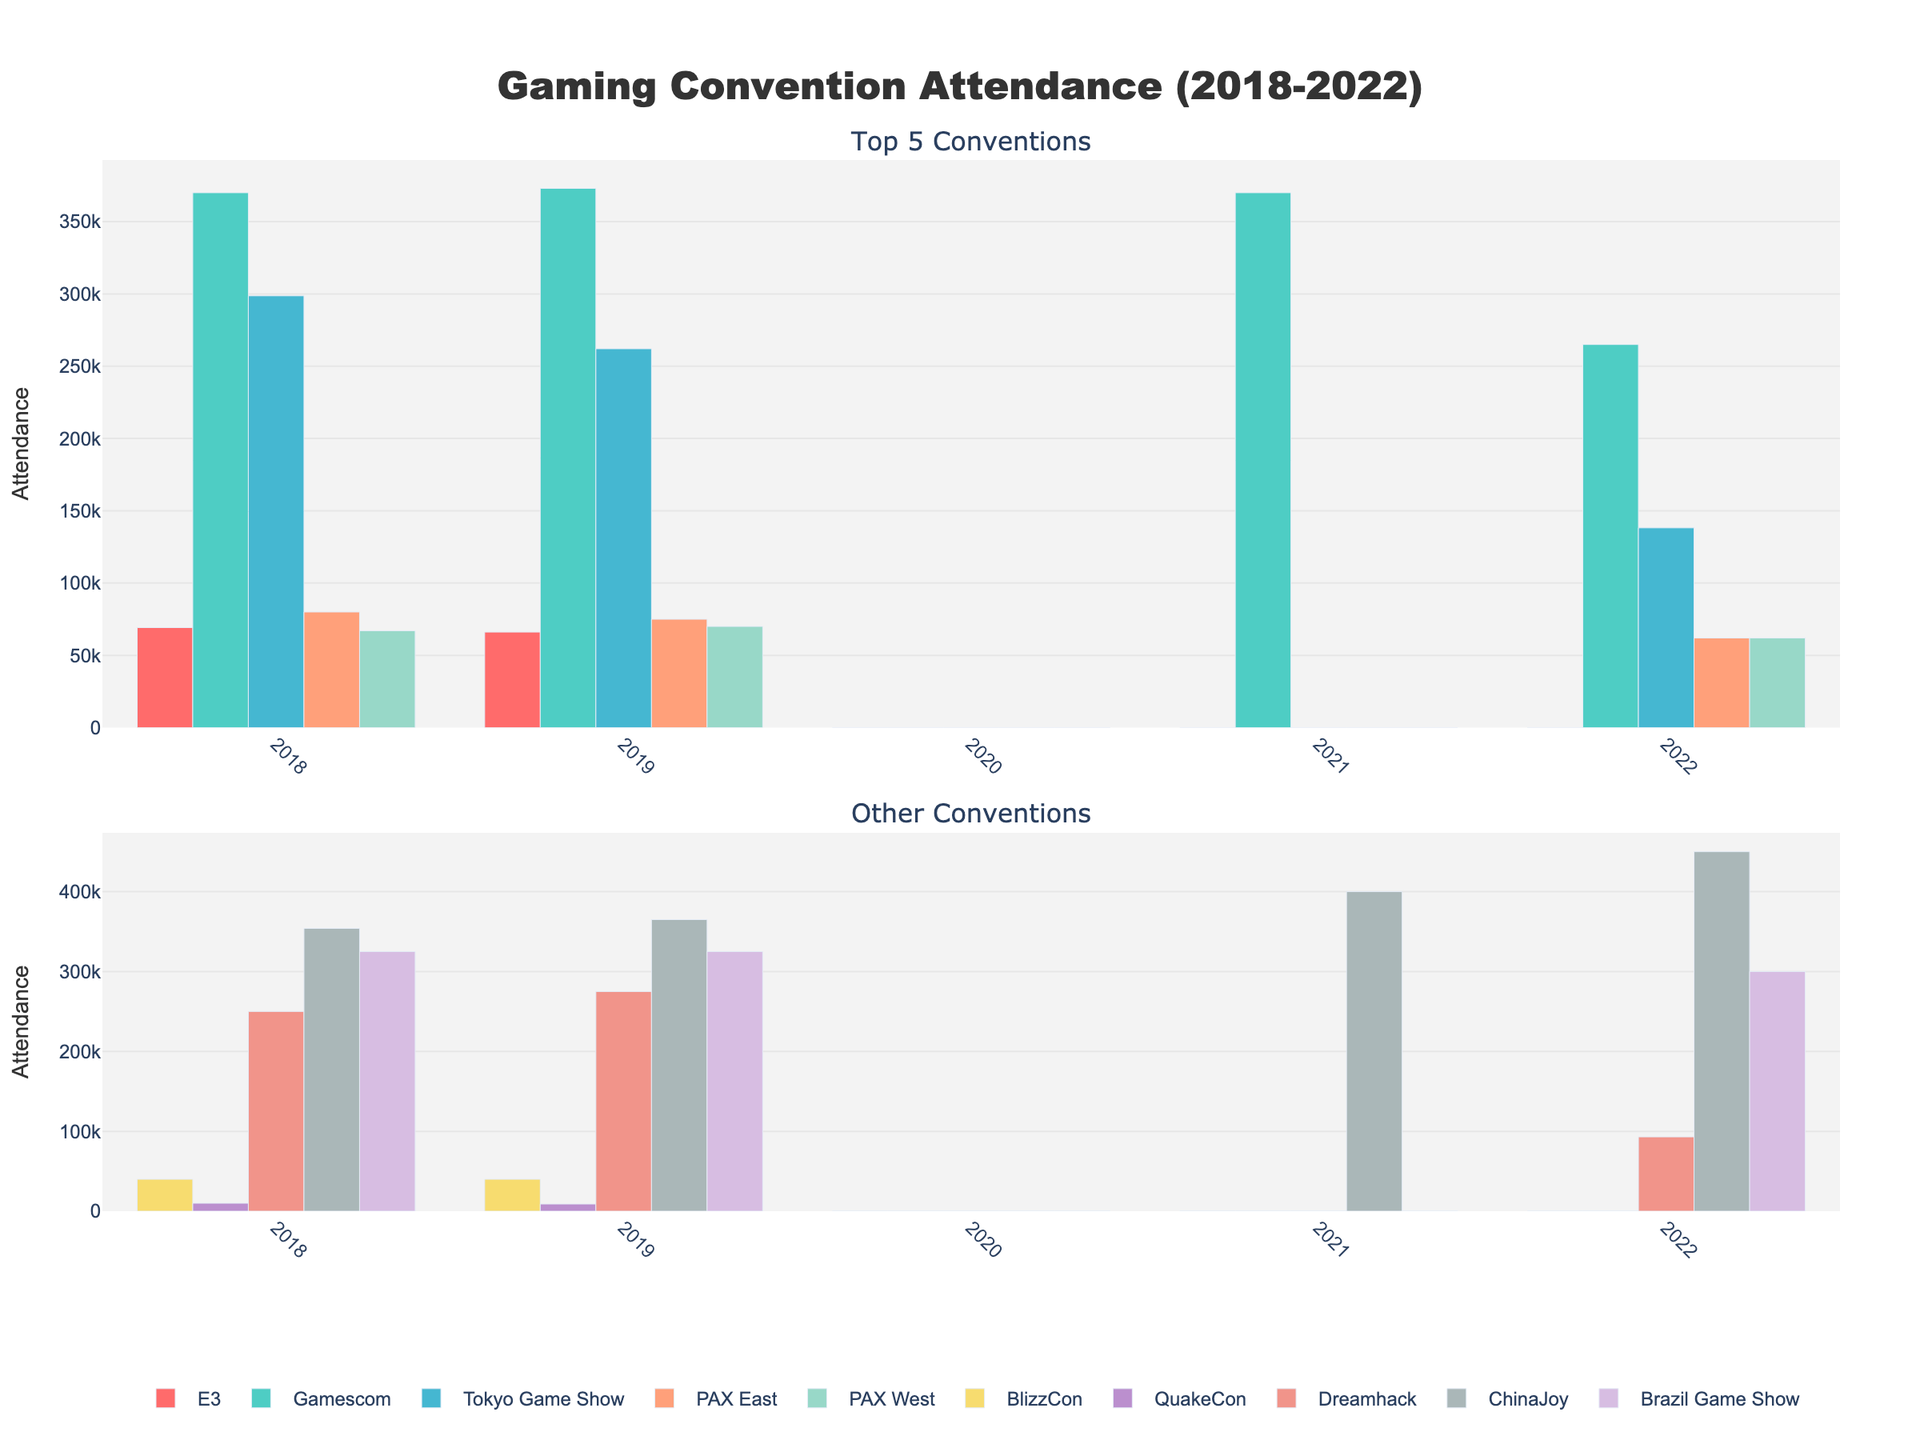What was the trend of Gamescom attendance over the years? Gamescom attendance starts from 370,000 in 2018, slightly increases to 373,000 in 2019. Due to COVID-19, it's zero in 2020. It resumes in 2021 with 370,000, followed by a drop to 265,000 in 2022. The trend shows stability followed by a sharp decrease.
Answer: Stable then decrease How many conventions had zero attendance in 2020? By observing the figure, all conventions listed show a bar height of zero in 2020. The total number of conventions is 10.
Answer: 10 Which convention had the highest attendance in 2022? ChinaJoy has the highest bar height in 2022 indicating the highest attendance of 450,000.
Answer: ChinaJoy What is the combined attendance of Tokyo Game Show and PAX East in 2022? Tokyo Game Show attendance in 2022 is 138,192, and PAX East is 62,000. Adding these gives 138,192 + 62,000 = 200,192.
Answer: 200,192 Which convention has a larger attendance: PAX West or PAX East in 2019? By comparing the bar heights, PAX West has an attendance of 70,000, while PAX East has 75,000 in 2019. Therefore, PAX East has a larger attendance.
Answer: PAX East What were the total attendances for BlizzCon and QuakeCon in 2018 and 2019 combined? Adding BlizzCon's attendances from 2018 (40,000) and 2019 (40,000), plus QuakeCon's attendances from 2018 (10,000) and 2019 (9,000): 40,000 + 40,000 + 10,000 + 9,000 = 99,000.
Answer: 99,000 Which convention showed a growing trend from 2021 to 2022? Analyzing the bar heights, only ChinaJoy showed a growth, increasing from 400,000 in 2021 to 450,000 in 2022.
Answer: ChinaJoy How does the attendance of Dreamhack in 2022 compare to that in 2019? The attendance in 2019 was 275,000 shown by a higher bar compared to 93,000 in 2022. Thus, there's a significant decrease in attendance.
Answer: Decrease What is the average attendance of the top 5 conventions in 2018? The top 5 conventions in 2018 are Gamescom (370,000), ChinaJoy (354,000), Tokyo Game Show (298,690), Dreamhack (250,000), and Brazil Game Show (325,000). Their combined attendance is 370,000 + 354,000 + 298,690 + 250,000 + 325,000 = 1,597,690. The average is 1,597,690 / 5 = 319,538.
Answer: 319,538 